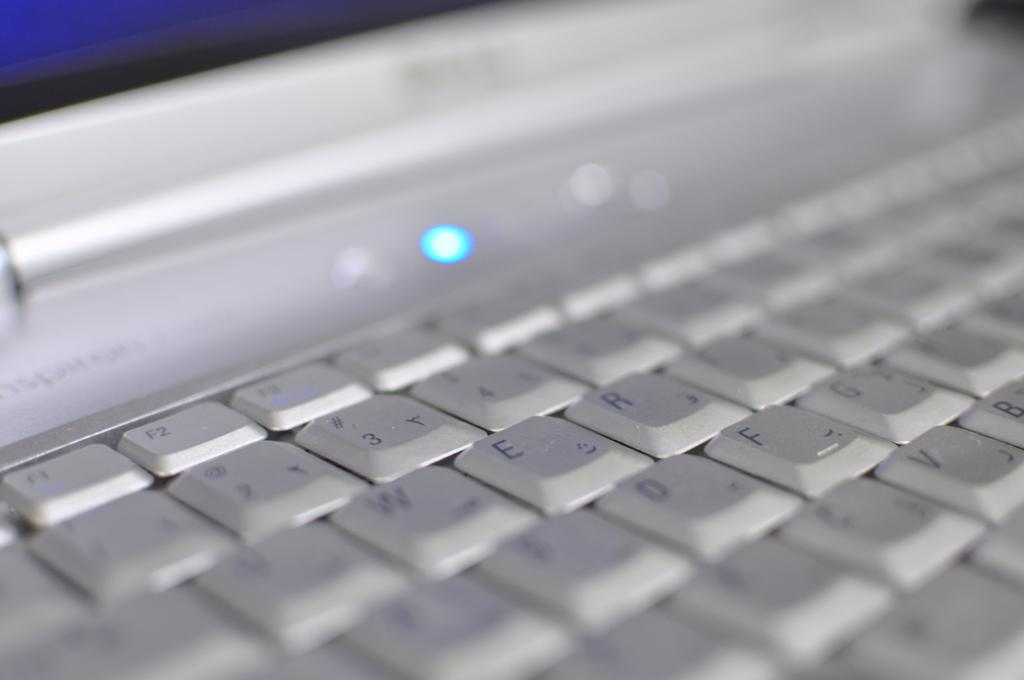Provide a one-sentence caption for the provided image. slightly blurry laptop keyboard with F1, F2, F3 visible along with numbers 1, 2, 3, 4 and also several letters visible. 